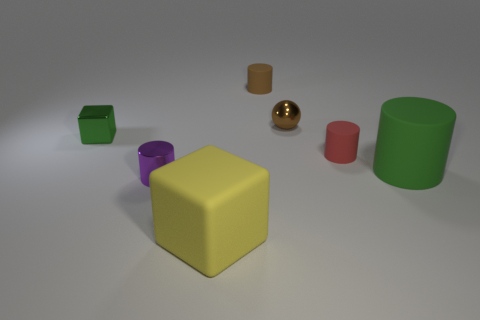There is a green thing that is behind the small red matte cylinder; what shape is it? The object in question is a green cube. Specifically, it's behind the smaller red cylinder and features a regular geometric shape with six faces, each of which is a square. 